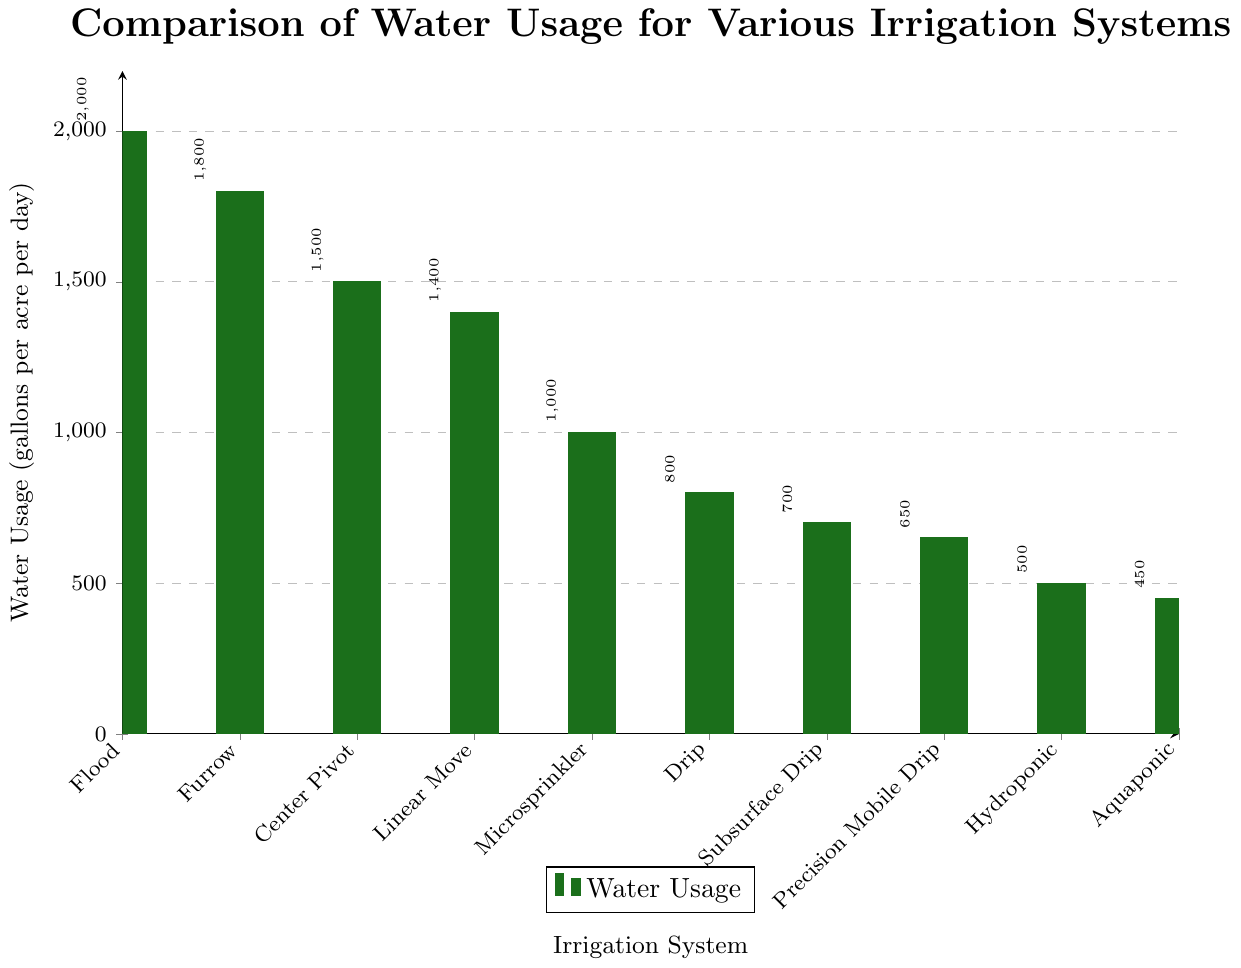Which irrigation system uses the most water? The bar for "Flood Irrigation" reaches the highest point on the graph.
Answer: Flood Irrigation How much more water does Flood Irrigation use compared to Aquaponic Systems? Subtract the water usage of Aquaponic Systems (450 gallons) from Flood Irrigation (2000 gallons). 2000 - 450 = 1550
Answer: 1550 gallons What is the average water usage of Center Pivot Sprinkler, Linear Move Sprinkler, Microsprinkler, and Drip Irrigation? Average is calculated by summing the water usage of the four systems and then dividing by the number of systems. (1500 + 1400 + 1000 + 800) / 4 = 4700 / 4 = 1175
Answer: 1175 gallons per acre per day Which irrigation system uses the least amount of water? The bar for "Aquaponic System" reaches the lowest point on the graph.
Answer: Aquaponic System Is the water usage of Drip Irrigation greater than that of Subsurface Drip Irrigation? The bar for Drip Irrigation is higher (800 gallons) compared to Subsurface Drip Irrigation (700 gallons).
Answer: Yes What is the difference in water usage between Furrow Irrigation and Hydroponic System? Subtract the water usage of Hydroponic System (500 gallons) from Furrow Irrigation (1800 gallons). 1800 - 500 = 1300
Answer: 1300 gallons How do the systems Microsprinkler and Drip Irrigation compare in terms of water usage? Compare the heights of the bars: Microsprinkler uses 1000 gallons, and Drip Irrigation uses 800 gallons. Microsprinkler uses more water.
Answer: Microsprinkler uses more water What is the total water usage of the three least water-consuming systems? Sum the water usage of Aquaponic System (450 gallons), Hydroponic System (500 gallons), and Precision Mobile Drip Irrigation (650 gallons). 450 + 500 + 650 = 1600
Answer: 1600 gallons per acre per day Which irrigation system has a water usage closest to the average of all the systems? First, calculate the total water usage of all systems: 2000 + 1800 + 1500 + 1400 + 1000 + 800 + 700 + 650 + 500 + 450 = 10800; then, divide by the number of systems: 10800 / 10 = 1080. The system closest to 1080 is Microsprinkler (1000 gallons).
Answer: Microsprinkler Are there more systems that use over 1000 gallons per acre per day or under 1000 gallons? Count the systems using over 1000 gallons (Flood, Furrow, Center Pivot, Linear Move, Microsprinkler) and those using under (Drip, Subsurface Drip, Precision Mobile Drip, Hydroponic, Aquaponic). There are 5 systems over and 5 systems under.
Answer: Equal 